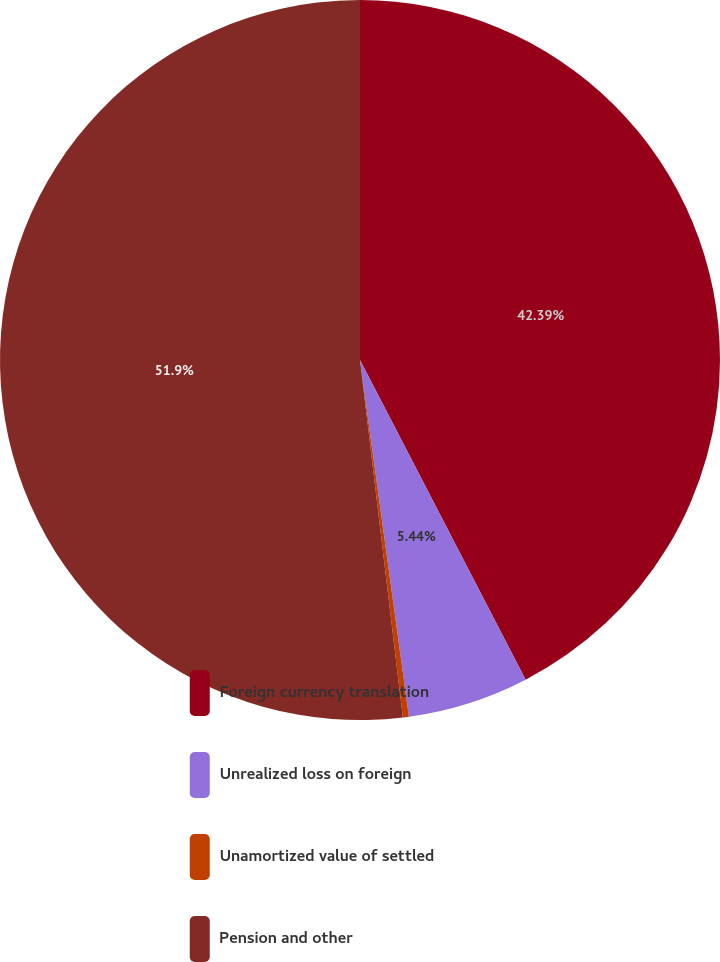Convert chart to OTSL. <chart><loc_0><loc_0><loc_500><loc_500><pie_chart><fcel>Foreign currency translation<fcel>Unrealized loss on foreign<fcel>Unamortized value of settled<fcel>Pension and other<nl><fcel>42.39%<fcel>5.44%<fcel>0.27%<fcel>51.9%<nl></chart> 